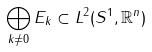Convert formula to latex. <formula><loc_0><loc_0><loc_500><loc_500>\bigoplus _ { k \neq 0 } E _ { k } \subset L ^ { 2 } ( S ^ { 1 } , { \mathbb { R } } ^ { n } )</formula> 